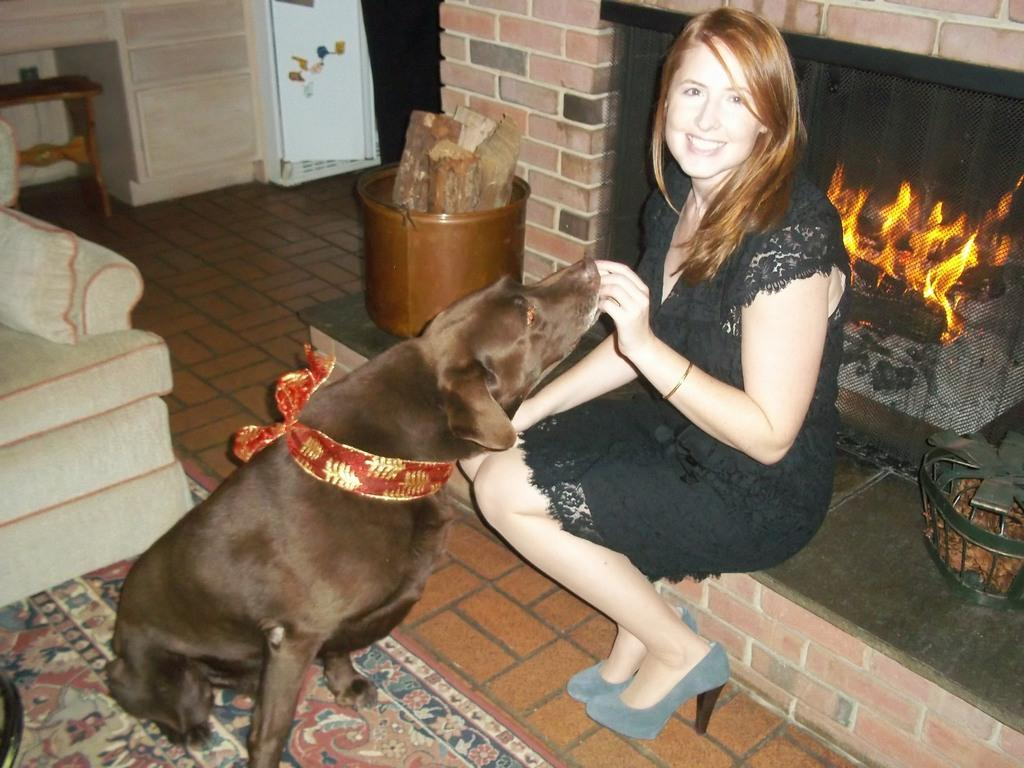What type of animal can be seen in the image? There is a dog in the image. Who is present in the image besides the dog? There is a woman in the image. What is the woman's facial expression? The woman is smiling. What piece of furniture is in front of the woman? There is a sofa bed in front of the woman. What architectural feature is behind the woman? There is a fireplace behind the woman. What type of jail can be seen in the image? There is no jail present in the image. What does the stick have to do with the woman's sneeze in the image? There is no stick or sneeze mentioned in the image. 